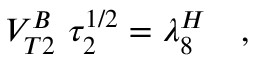Convert formula to latex. <formula><loc_0><loc_0><loc_500><loc_500>V _ { T 2 } ^ { B } \ \tau _ { 2 } ^ { 1 / 2 } = \lambda _ { 8 } ^ { H } \quad ,</formula> 